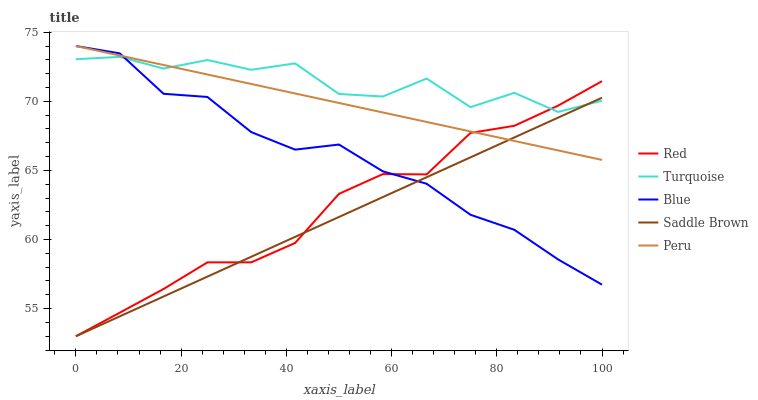Does Saddle Brown have the minimum area under the curve?
Answer yes or no. Yes. Does Turquoise have the maximum area under the curve?
Answer yes or no. Yes. Does Peru have the minimum area under the curve?
Answer yes or no. No. Does Peru have the maximum area under the curve?
Answer yes or no. No. Is Peru the smoothest?
Answer yes or no. Yes. Is Turquoise the roughest?
Answer yes or no. Yes. Is Turquoise the smoothest?
Answer yes or no. No. Is Peru the roughest?
Answer yes or no. No. Does Peru have the lowest value?
Answer yes or no. No. Does Turquoise have the highest value?
Answer yes or no. No. 